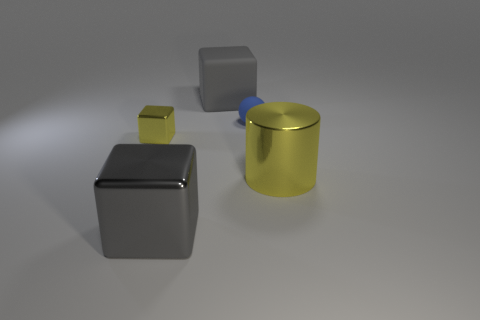Subtract all big shiny blocks. How many blocks are left? 2 Add 5 small blue rubber things. How many objects exist? 10 Subtract all yellow cubes. How many cubes are left? 2 Subtract all cubes. How many objects are left? 2 Subtract 1 cylinders. How many cylinders are left? 0 Subtract all gray spheres. How many gray blocks are left? 2 Subtract all green metal things. Subtract all blue matte spheres. How many objects are left? 4 Add 3 large cubes. How many large cubes are left? 5 Add 2 tiny balls. How many tiny balls exist? 3 Subtract 1 yellow blocks. How many objects are left? 4 